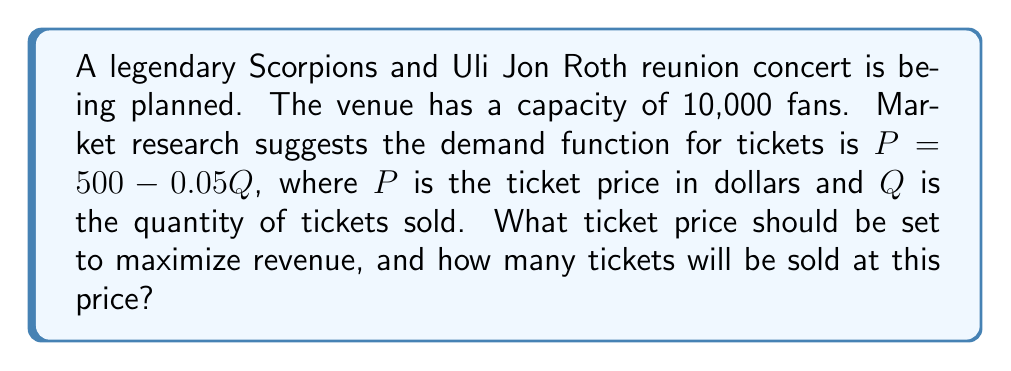Can you answer this question? To solve this optimization problem, we need to follow these steps:

1) First, we need to formulate the revenue function. Revenue is price times quantity:

   $R = P \cdot Q$

2) We substitute the demand function into this equation:

   $R = (500 - 0.05Q) \cdot Q = 500Q - 0.05Q^2$

3) To find the maximum revenue, we need to differentiate $R$ with respect to $Q$ and set it to zero:

   $$\frac{dR}{dQ} = 500 - 0.1Q = 0$$

4) Solve this equation:

   $500 - 0.1Q = 0$
   $-0.1Q = -500$
   $Q = 5000$

5) To confirm this is a maximum (not a minimum), we can check the second derivative:

   $$\frac{d^2R}{dQ^2} = -0.1 < 0$$

   This confirms we have a maximum.

6) Now that we know the optimal quantity, we can find the optimal price by plugging $Q = 5000$ into the demand function:

   $P = 500 - 0.05(5000) = 500 - 250 = 250$

7) Finally, we should check if this solution respects the venue capacity constraint. Since 5000 < 10000, the constraint is not binding and our solution is valid.
Answer: The optimal ticket price is $250, and 5000 tickets will be sold at this price. 